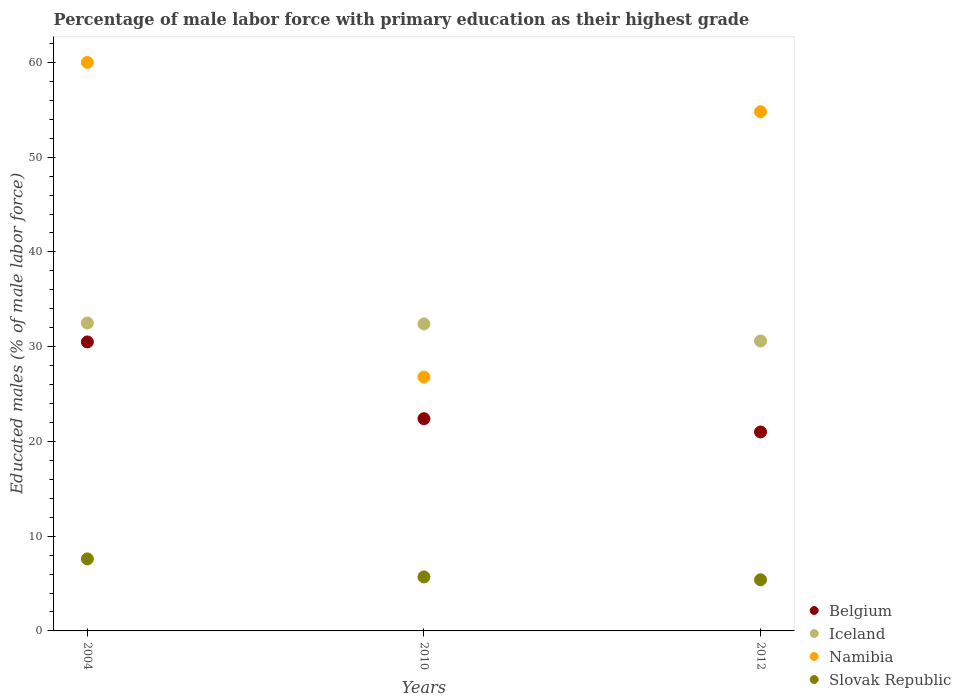Is the number of dotlines equal to the number of legend labels?
Your answer should be compact. Yes. Across all years, what is the maximum percentage of male labor force with primary education in Slovak Republic?
Offer a very short reply. 7.6. Across all years, what is the minimum percentage of male labor force with primary education in Iceland?
Your answer should be compact. 30.6. In which year was the percentage of male labor force with primary education in Namibia minimum?
Your answer should be very brief. 2010. What is the total percentage of male labor force with primary education in Namibia in the graph?
Your response must be concise. 141.6. What is the difference between the percentage of male labor force with primary education in Namibia in 2010 and that in 2012?
Your response must be concise. -28. What is the difference between the percentage of male labor force with primary education in Iceland in 2004 and the percentage of male labor force with primary education in Namibia in 2012?
Your response must be concise. -22.3. What is the average percentage of male labor force with primary education in Namibia per year?
Offer a very short reply. 47.2. In the year 2012, what is the difference between the percentage of male labor force with primary education in Belgium and percentage of male labor force with primary education in Namibia?
Your answer should be very brief. -33.8. What is the ratio of the percentage of male labor force with primary education in Namibia in 2004 to that in 2010?
Your response must be concise. 2.24. Is the difference between the percentage of male labor force with primary education in Belgium in 2004 and 2012 greater than the difference between the percentage of male labor force with primary education in Namibia in 2004 and 2012?
Keep it short and to the point. Yes. What is the difference between the highest and the second highest percentage of male labor force with primary education in Iceland?
Ensure brevity in your answer.  0.1. Is the percentage of male labor force with primary education in Namibia strictly greater than the percentage of male labor force with primary education in Slovak Republic over the years?
Offer a terse response. Yes. Is the percentage of male labor force with primary education in Belgium strictly less than the percentage of male labor force with primary education in Iceland over the years?
Provide a short and direct response. Yes. How many dotlines are there?
Make the answer very short. 4. Are the values on the major ticks of Y-axis written in scientific E-notation?
Your answer should be very brief. No. What is the title of the graph?
Offer a terse response. Percentage of male labor force with primary education as their highest grade. Does "Romania" appear as one of the legend labels in the graph?
Offer a terse response. No. What is the label or title of the X-axis?
Offer a terse response. Years. What is the label or title of the Y-axis?
Your answer should be compact. Educated males (% of male labor force). What is the Educated males (% of male labor force) in Belgium in 2004?
Provide a succinct answer. 30.5. What is the Educated males (% of male labor force) in Iceland in 2004?
Offer a very short reply. 32.5. What is the Educated males (% of male labor force) in Namibia in 2004?
Give a very brief answer. 60. What is the Educated males (% of male labor force) in Slovak Republic in 2004?
Provide a succinct answer. 7.6. What is the Educated males (% of male labor force) in Belgium in 2010?
Provide a succinct answer. 22.4. What is the Educated males (% of male labor force) of Iceland in 2010?
Offer a very short reply. 32.4. What is the Educated males (% of male labor force) of Namibia in 2010?
Your answer should be compact. 26.8. What is the Educated males (% of male labor force) in Slovak Republic in 2010?
Make the answer very short. 5.7. What is the Educated males (% of male labor force) in Iceland in 2012?
Offer a very short reply. 30.6. What is the Educated males (% of male labor force) in Namibia in 2012?
Make the answer very short. 54.8. What is the Educated males (% of male labor force) in Slovak Republic in 2012?
Your response must be concise. 5.4. Across all years, what is the maximum Educated males (% of male labor force) in Belgium?
Your response must be concise. 30.5. Across all years, what is the maximum Educated males (% of male labor force) of Iceland?
Offer a terse response. 32.5. Across all years, what is the maximum Educated males (% of male labor force) of Namibia?
Provide a short and direct response. 60. Across all years, what is the maximum Educated males (% of male labor force) of Slovak Republic?
Your answer should be compact. 7.6. Across all years, what is the minimum Educated males (% of male labor force) of Iceland?
Ensure brevity in your answer.  30.6. Across all years, what is the minimum Educated males (% of male labor force) in Namibia?
Ensure brevity in your answer.  26.8. Across all years, what is the minimum Educated males (% of male labor force) of Slovak Republic?
Your answer should be very brief. 5.4. What is the total Educated males (% of male labor force) of Belgium in the graph?
Your response must be concise. 73.9. What is the total Educated males (% of male labor force) of Iceland in the graph?
Provide a succinct answer. 95.5. What is the total Educated males (% of male labor force) of Namibia in the graph?
Your response must be concise. 141.6. What is the total Educated males (% of male labor force) of Slovak Republic in the graph?
Make the answer very short. 18.7. What is the difference between the Educated males (% of male labor force) of Belgium in 2004 and that in 2010?
Provide a short and direct response. 8.1. What is the difference between the Educated males (% of male labor force) in Namibia in 2004 and that in 2010?
Provide a short and direct response. 33.2. What is the difference between the Educated males (% of male labor force) of Belgium in 2004 and that in 2012?
Your answer should be very brief. 9.5. What is the difference between the Educated males (% of male labor force) of Iceland in 2004 and that in 2012?
Offer a terse response. 1.9. What is the difference between the Educated males (% of male labor force) of Slovak Republic in 2004 and that in 2012?
Give a very brief answer. 2.2. What is the difference between the Educated males (% of male labor force) of Iceland in 2010 and that in 2012?
Keep it short and to the point. 1.8. What is the difference between the Educated males (% of male labor force) of Namibia in 2010 and that in 2012?
Your response must be concise. -28. What is the difference between the Educated males (% of male labor force) of Belgium in 2004 and the Educated males (% of male labor force) of Iceland in 2010?
Provide a succinct answer. -1.9. What is the difference between the Educated males (% of male labor force) of Belgium in 2004 and the Educated males (% of male labor force) of Slovak Republic in 2010?
Your answer should be compact. 24.8. What is the difference between the Educated males (% of male labor force) in Iceland in 2004 and the Educated males (% of male labor force) in Namibia in 2010?
Provide a short and direct response. 5.7. What is the difference between the Educated males (% of male labor force) in Iceland in 2004 and the Educated males (% of male labor force) in Slovak Republic in 2010?
Offer a terse response. 26.8. What is the difference between the Educated males (% of male labor force) in Namibia in 2004 and the Educated males (% of male labor force) in Slovak Republic in 2010?
Ensure brevity in your answer.  54.3. What is the difference between the Educated males (% of male labor force) of Belgium in 2004 and the Educated males (% of male labor force) of Iceland in 2012?
Provide a short and direct response. -0.1. What is the difference between the Educated males (% of male labor force) of Belgium in 2004 and the Educated males (% of male labor force) of Namibia in 2012?
Your answer should be compact. -24.3. What is the difference between the Educated males (% of male labor force) in Belgium in 2004 and the Educated males (% of male labor force) in Slovak Republic in 2012?
Provide a short and direct response. 25.1. What is the difference between the Educated males (% of male labor force) in Iceland in 2004 and the Educated males (% of male labor force) in Namibia in 2012?
Your answer should be very brief. -22.3. What is the difference between the Educated males (% of male labor force) in Iceland in 2004 and the Educated males (% of male labor force) in Slovak Republic in 2012?
Give a very brief answer. 27.1. What is the difference between the Educated males (% of male labor force) in Namibia in 2004 and the Educated males (% of male labor force) in Slovak Republic in 2012?
Ensure brevity in your answer.  54.6. What is the difference between the Educated males (% of male labor force) of Belgium in 2010 and the Educated males (% of male labor force) of Iceland in 2012?
Make the answer very short. -8.2. What is the difference between the Educated males (% of male labor force) of Belgium in 2010 and the Educated males (% of male labor force) of Namibia in 2012?
Keep it short and to the point. -32.4. What is the difference between the Educated males (% of male labor force) in Iceland in 2010 and the Educated males (% of male labor force) in Namibia in 2012?
Make the answer very short. -22.4. What is the difference between the Educated males (% of male labor force) of Iceland in 2010 and the Educated males (% of male labor force) of Slovak Republic in 2012?
Offer a terse response. 27. What is the difference between the Educated males (% of male labor force) of Namibia in 2010 and the Educated males (% of male labor force) of Slovak Republic in 2012?
Give a very brief answer. 21.4. What is the average Educated males (% of male labor force) of Belgium per year?
Provide a short and direct response. 24.63. What is the average Educated males (% of male labor force) in Iceland per year?
Provide a succinct answer. 31.83. What is the average Educated males (% of male labor force) of Namibia per year?
Offer a terse response. 47.2. What is the average Educated males (% of male labor force) of Slovak Republic per year?
Your response must be concise. 6.23. In the year 2004, what is the difference between the Educated males (% of male labor force) in Belgium and Educated males (% of male labor force) in Namibia?
Provide a short and direct response. -29.5. In the year 2004, what is the difference between the Educated males (% of male labor force) in Belgium and Educated males (% of male labor force) in Slovak Republic?
Offer a terse response. 22.9. In the year 2004, what is the difference between the Educated males (% of male labor force) in Iceland and Educated males (% of male labor force) in Namibia?
Your answer should be very brief. -27.5. In the year 2004, what is the difference between the Educated males (% of male labor force) of Iceland and Educated males (% of male labor force) of Slovak Republic?
Make the answer very short. 24.9. In the year 2004, what is the difference between the Educated males (% of male labor force) in Namibia and Educated males (% of male labor force) in Slovak Republic?
Your answer should be compact. 52.4. In the year 2010, what is the difference between the Educated males (% of male labor force) of Iceland and Educated males (% of male labor force) of Namibia?
Your response must be concise. 5.6. In the year 2010, what is the difference between the Educated males (% of male labor force) in Iceland and Educated males (% of male labor force) in Slovak Republic?
Your response must be concise. 26.7. In the year 2010, what is the difference between the Educated males (% of male labor force) in Namibia and Educated males (% of male labor force) in Slovak Republic?
Offer a very short reply. 21.1. In the year 2012, what is the difference between the Educated males (% of male labor force) in Belgium and Educated males (% of male labor force) in Iceland?
Your response must be concise. -9.6. In the year 2012, what is the difference between the Educated males (% of male labor force) of Belgium and Educated males (% of male labor force) of Namibia?
Provide a short and direct response. -33.8. In the year 2012, what is the difference between the Educated males (% of male labor force) in Iceland and Educated males (% of male labor force) in Namibia?
Provide a short and direct response. -24.2. In the year 2012, what is the difference between the Educated males (% of male labor force) in Iceland and Educated males (% of male labor force) in Slovak Republic?
Ensure brevity in your answer.  25.2. In the year 2012, what is the difference between the Educated males (% of male labor force) in Namibia and Educated males (% of male labor force) in Slovak Republic?
Provide a succinct answer. 49.4. What is the ratio of the Educated males (% of male labor force) of Belgium in 2004 to that in 2010?
Give a very brief answer. 1.36. What is the ratio of the Educated males (% of male labor force) of Iceland in 2004 to that in 2010?
Make the answer very short. 1. What is the ratio of the Educated males (% of male labor force) in Namibia in 2004 to that in 2010?
Provide a succinct answer. 2.24. What is the ratio of the Educated males (% of male labor force) of Slovak Republic in 2004 to that in 2010?
Give a very brief answer. 1.33. What is the ratio of the Educated males (% of male labor force) of Belgium in 2004 to that in 2012?
Ensure brevity in your answer.  1.45. What is the ratio of the Educated males (% of male labor force) of Iceland in 2004 to that in 2012?
Give a very brief answer. 1.06. What is the ratio of the Educated males (% of male labor force) of Namibia in 2004 to that in 2012?
Make the answer very short. 1.09. What is the ratio of the Educated males (% of male labor force) of Slovak Republic in 2004 to that in 2012?
Ensure brevity in your answer.  1.41. What is the ratio of the Educated males (% of male labor force) in Belgium in 2010 to that in 2012?
Ensure brevity in your answer.  1.07. What is the ratio of the Educated males (% of male labor force) in Iceland in 2010 to that in 2012?
Your response must be concise. 1.06. What is the ratio of the Educated males (% of male labor force) of Namibia in 2010 to that in 2012?
Give a very brief answer. 0.49. What is the ratio of the Educated males (% of male labor force) of Slovak Republic in 2010 to that in 2012?
Ensure brevity in your answer.  1.06. What is the difference between the highest and the second highest Educated males (% of male labor force) of Belgium?
Provide a succinct answer. 8.1. What is the difference between the highest and the second highest Educated males (% of male labor force) in Slovak Republic?
Provide a short and direct response. 1.9. What is the difference between the highest and the lowest Educated males (% of male labor force) of Namibia?
Offer a very short reply. 33.2. 